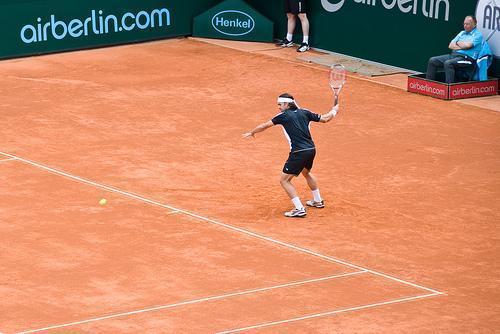How many people are playing tennis?
Give a very brief answer. 1. 